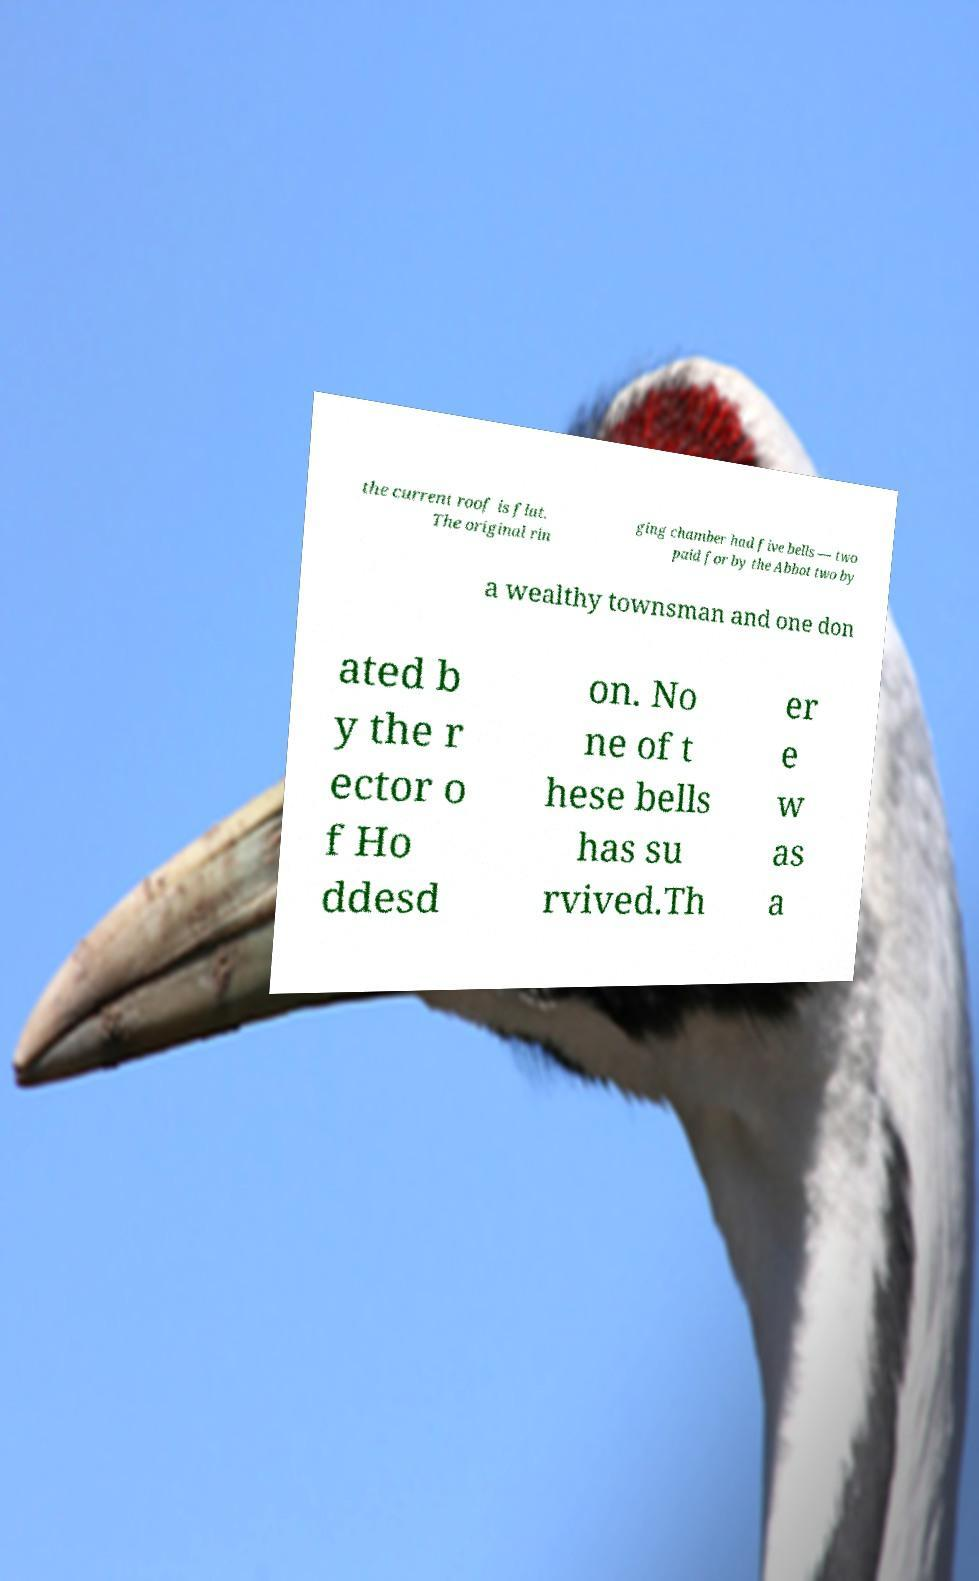Could you extract and type out the text from this image? the current roof is flat. The original rin ging chamber had five bells — two paid for by the Abbot two by a wealthy townsman and one don ated b y the r ector o f Ho ddesd on. No ne of t hese bells has su rvived.Th er e w as a 